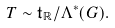<formula> <loc_0><loc_0><loc_500><loc_500>T \sim \mathfrak t _ { \mathbb { R } } / \Lambda ^ { * } ( G ) .</formula> 